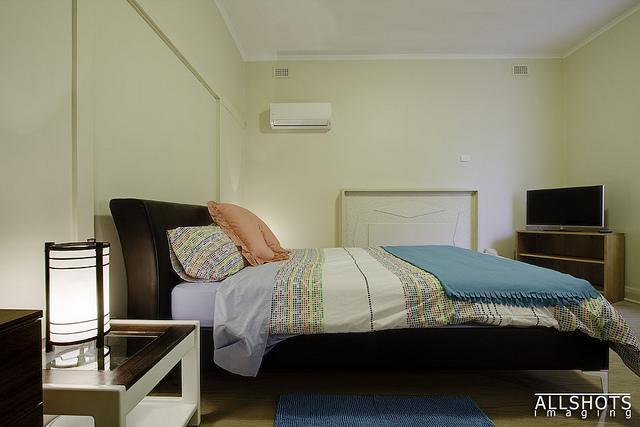How many items are on the bookshelf in the background?
Give a very brief answer. 1. 